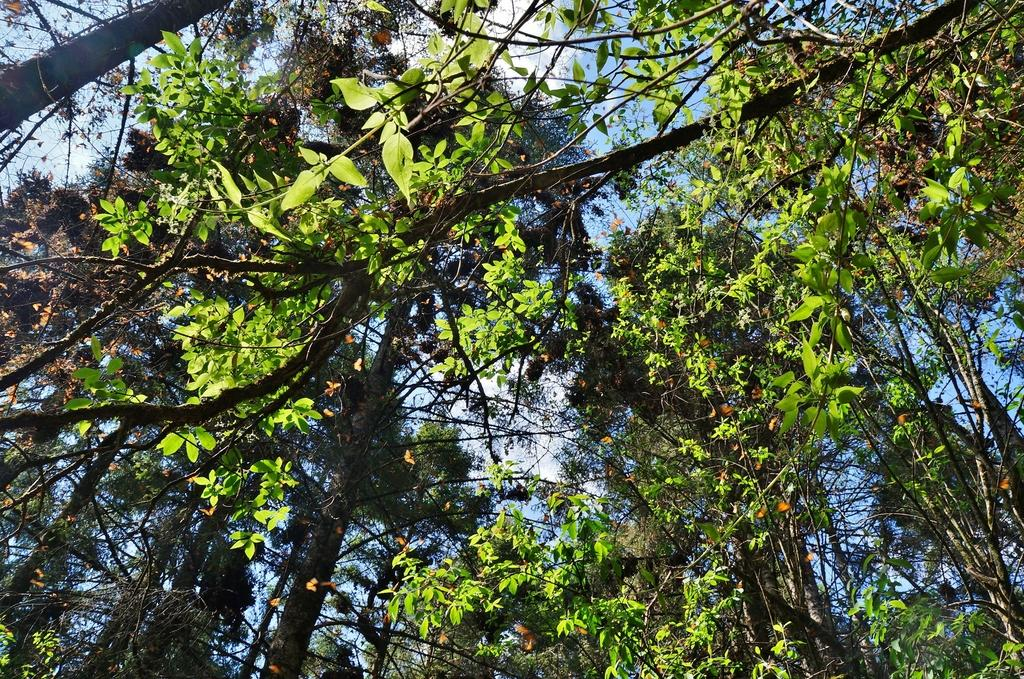What type of vegetation is present in the image? There are trees with leaves in the image. What part of the natural environment is visible in the background of the image? The sky is visible in the background of the image. Can you see a face carved into one of the trees in the image? There is no face carved into any of the trees in the image. What type of terrain is visible in the image? The image does not show any specific terrain, only trees and the sky. 